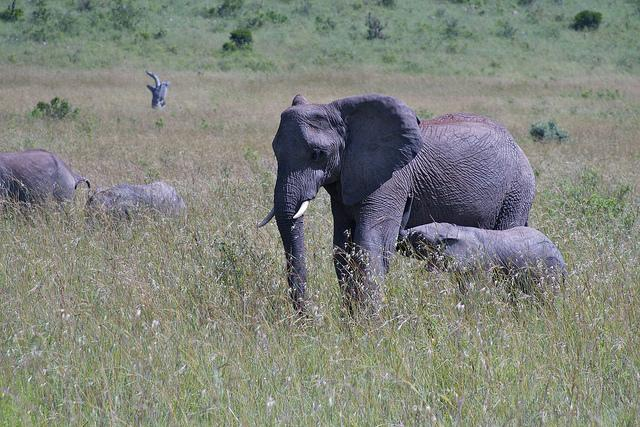What is the sharpest item here? tusk 